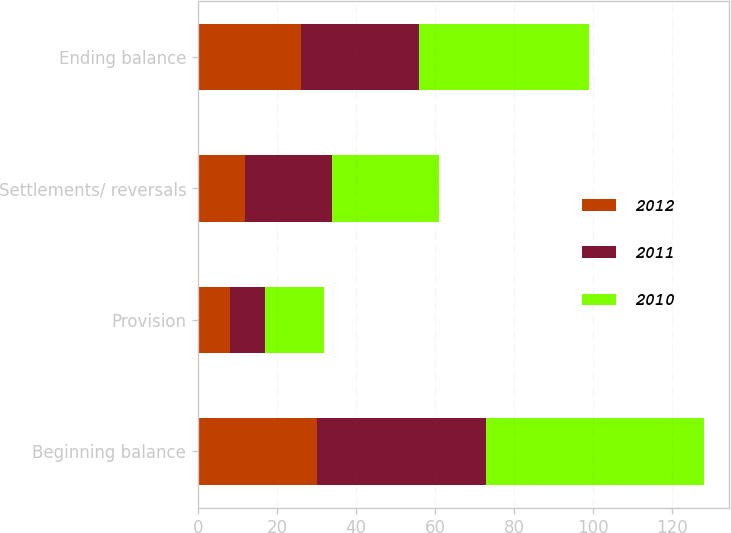Convert chart. <chart><loc_0><loc_0><loc_500><loc_500><stacked_bar_chart><ecel><fcel>Beginning balance<fcel>Provision<fcel>Settlements/ reversals<fcel>Ending balance<nl><fcel>2012<fcel>30<fcel>8<fcel>12<fcel>26<nl><fcel>2011<fcel>43<fcel>9<fcel>22<fcel>30<nl><fcel>2010<fcel>55<fcel>15<fcel>27<fcel>43<nl></chart> 